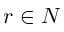<formula> <loc_0><loc_0><loc_500><loc_500>r \in N</formula> 